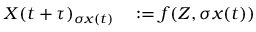Convert formula to latex. <formula><loc_0><loc_0><loc_500><loc_500>\begin{array} { r l } { X ( t + \tau ) _ { \sigma x ( t ) } } & \colon = f ( Z , \sigma x ( t ) ) } \end{array}</formula> 